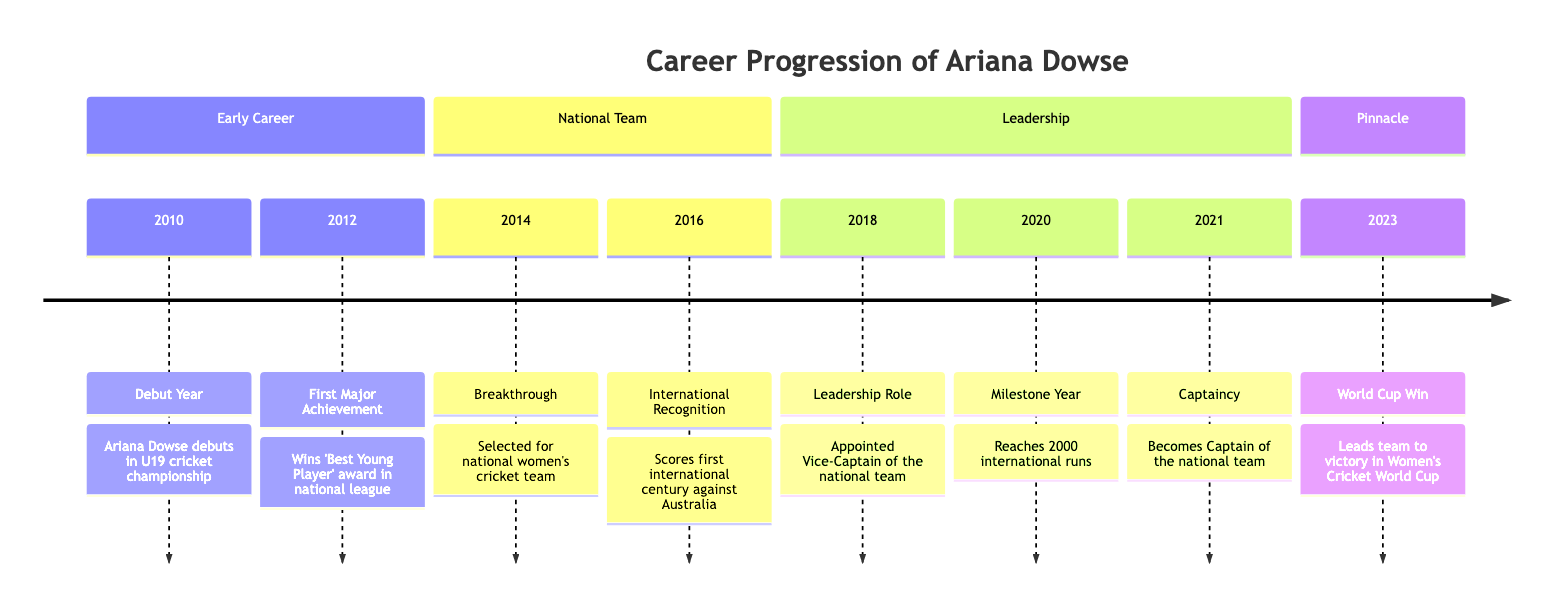What year did Ariana Dowse make her debut? The timeline shows that Ariana Dowse debuted in U19 cricket championship in the year 2010.
Answer: 2010 What award did Ariana Dowse win in 2012? According to the timeline, Ariana Dowse won the 'Best Young Player' award in the national league in 2012.
Answer: Best Young Player In what year was Ariana Dowse selected for the national women's cricket team? The diagram indicates that Ariana Dowse was selected for the national women's cricket team in 2014.
Answer: 2014 How many international runs did Ariana Dowse reach in 2020? The timeline specifies that Ariana Dowse reached 2000 international runs in the year 2020.
Answer: 2000 What significant achievement did Ariana Dowse accomplish in 2023? The diagram reveals that in 2023, Ariana Dowse led her team to victory in the Women's Cricket World Cup.
Answer: World Cup Win What role did Ariana Dowse take on in 2018? The timeline states that Ariana Dowse was appointed Vice-Captain of the national team in 2018.
Answer: Vice-Captain In which year did Ariana Dowse score her first international century? According to the timeline, Ariana Dowse scored her first international century against Australia in 2016.
Answer: 2016 Which year marked Ariana Dowse’s captaincy of the national team? The timeline clearly marks that Ariana Dowse became the Captain of the national team in 2021.
Answer: 2021 How many major milestones are listed in the early career section of the diagram? By reviewing the early career section, there are two major milestones highlighted: her debut in 2010 and the 'Best Young Player' award in 2012.
Answer: 2 